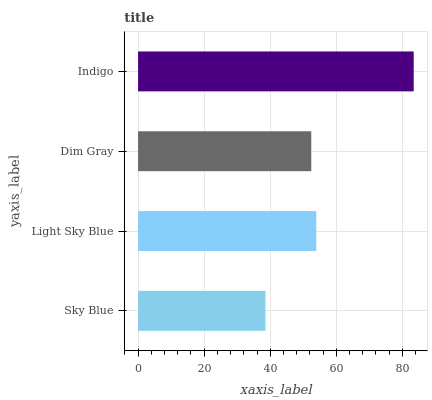Is Sky Blue the minimum?
Answer yes or no. Yes. Is Indigo the maximum?
Answer yes or no. Yes. Is Light Sky Blue the minimum?
Answer yes or no. No. Is Light Sky Blue the maximum?
Answer yes or no. No. Is Light Sky Blue greater than Sky Blue?
Answer yes or no. Yes. Is Sky Blue less than Light Sky Blue?
Answer yes or no. Yes. Is Sky Blue greater than Light Sky Blue?
Answer yes or no. No. Is Light Sky Blue less than Sky Blue?
Answer yes or no. No. Is Light Sky Blue the high median?
Answer yes or no. Yes. Is Dim Gray the low median?
Answer yes or no. Yes. Is Indigo the high median?
Answer yes or no. No. Is Sky Blue the low median?
Answer yes or no. No. 